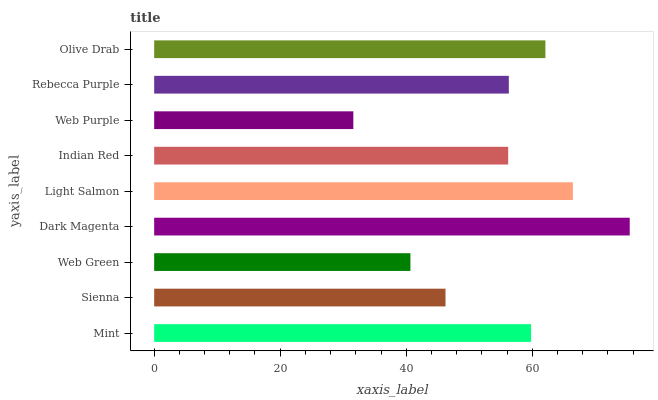Is Web Purple the minimum?
Answer yes or no. Yes. Is Dark Magenta the maximum?
Answer yes or no. Yes. Is Sienna the minimum?
Answer yes or no. No. Is Sienna the maximum?
Answer yes or no. No. Is Mint greater than Sienna?
Answer yes or no. Yes. Is Sienna less than Mint?
Answer yes or no. Yes. Is Sienna greater than Mint?
Answer yes or no. No. Is Mint less than Sienna?
Answer yes or no. No. Is Rebecca Purple the high median?
Answer yes or no. Yes. Is Rebecca Purple the low median?
Answer yes or no. Yes. Is Indian Red the high median?
Answer yes or no. No. Is Dark Magenta the low median?
Answer yes or no. No. 